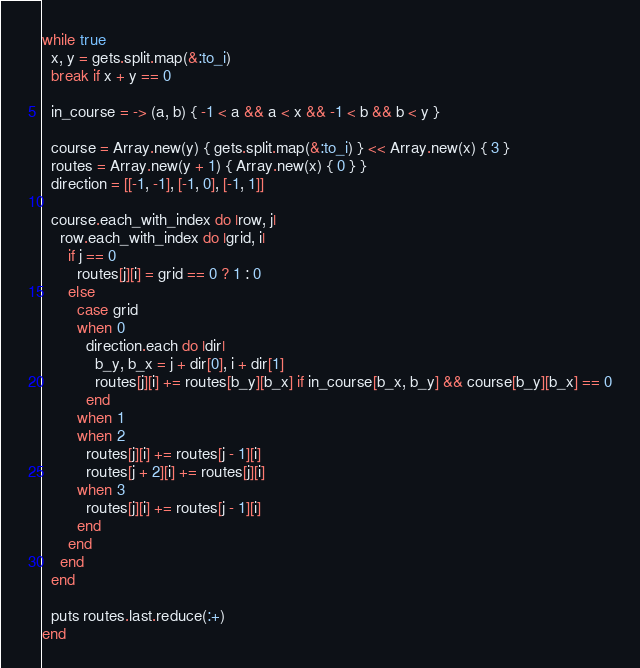<code> <loc_0><loc_0><loc_500><loc_500><_Ruby_>while true
  x, y = gets.split.map(&:to_i)
  break if x + y == 0
  
  in_course = -> (a, b) { -1 < a && a < x && -1 < b && b < y }
  
  course = Array.new(y) { gets.split.map(&:to_i) } << Array.new(x) { 3 }
  routes = Array.new(y + 1) { Array.new(x) { 0 } }
  direction = [[-1, -1], [-1, 0], [-1, 1]]
  
  course.each_with_index do |row, j|
    row.each_with_index do |grid, i|
      if j == 0
        routes[j][i] = grid == 0 ? 1 : 0
      else
        case grid
        when 0
          direction.each do |dir|
            b_y, b_x = j + dir[0], i + dir[1]
            routes[j][i] += routes[b_y][b_x] if in_course[b_x, b_y] && course[b_y][b_x] == 0
          end
        when 1
        when 2
          routes[j][i] += routes[j - 1][i]
          routes[j + 2][i] += routes[j][i]
        when 3
          routes[j][i] += routes[j - 1][i]
        end
      end
    end
  end
  
  puts routes.last.reduce(:+)
end</code> 